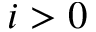Convert formula to latex. <formula><loc_0><loc_0><loc_500><loc_500>i > 0</formula> 